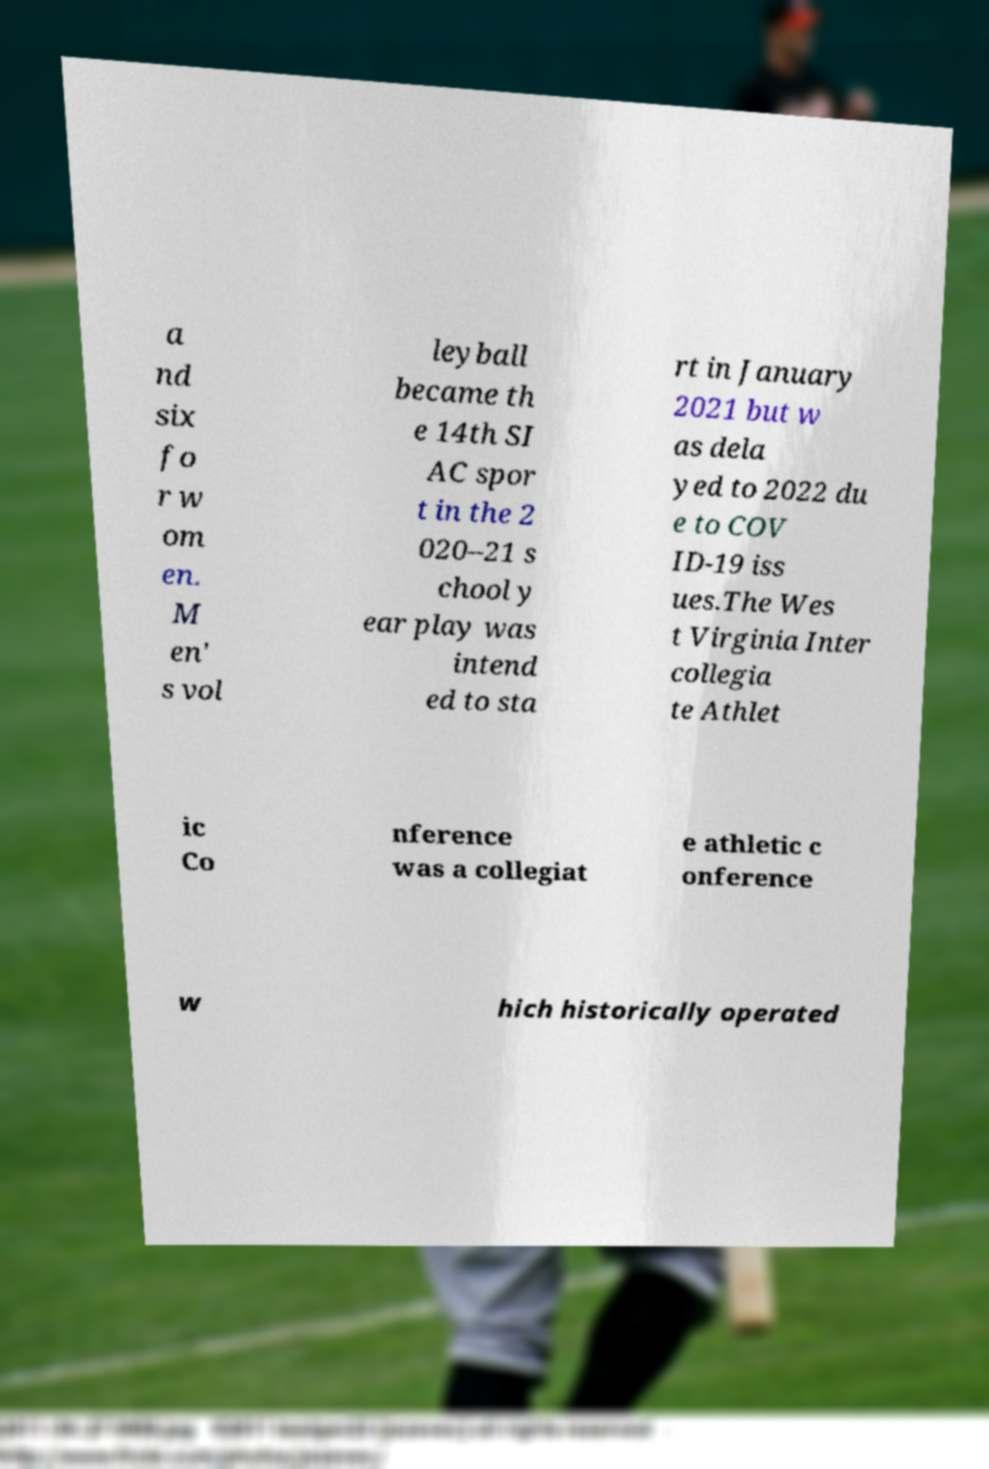There's text embedded in this image that I need extracted. Can you transcribe it verbatim? a nd six fo r w om en. M en' s vol leyball became th e 14th SI AC spor t in the 2 020–21 s chool y ear play was intend ed to sta rt in January 2021 but w as dela yed to 2022 du e to COV ID-19 iss ues.The Wes t Virginia Inter collegia te Athlet ic Co nference was a collegiat e athletic c onference w hich historically operated 